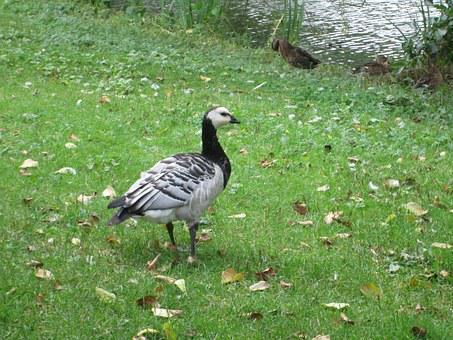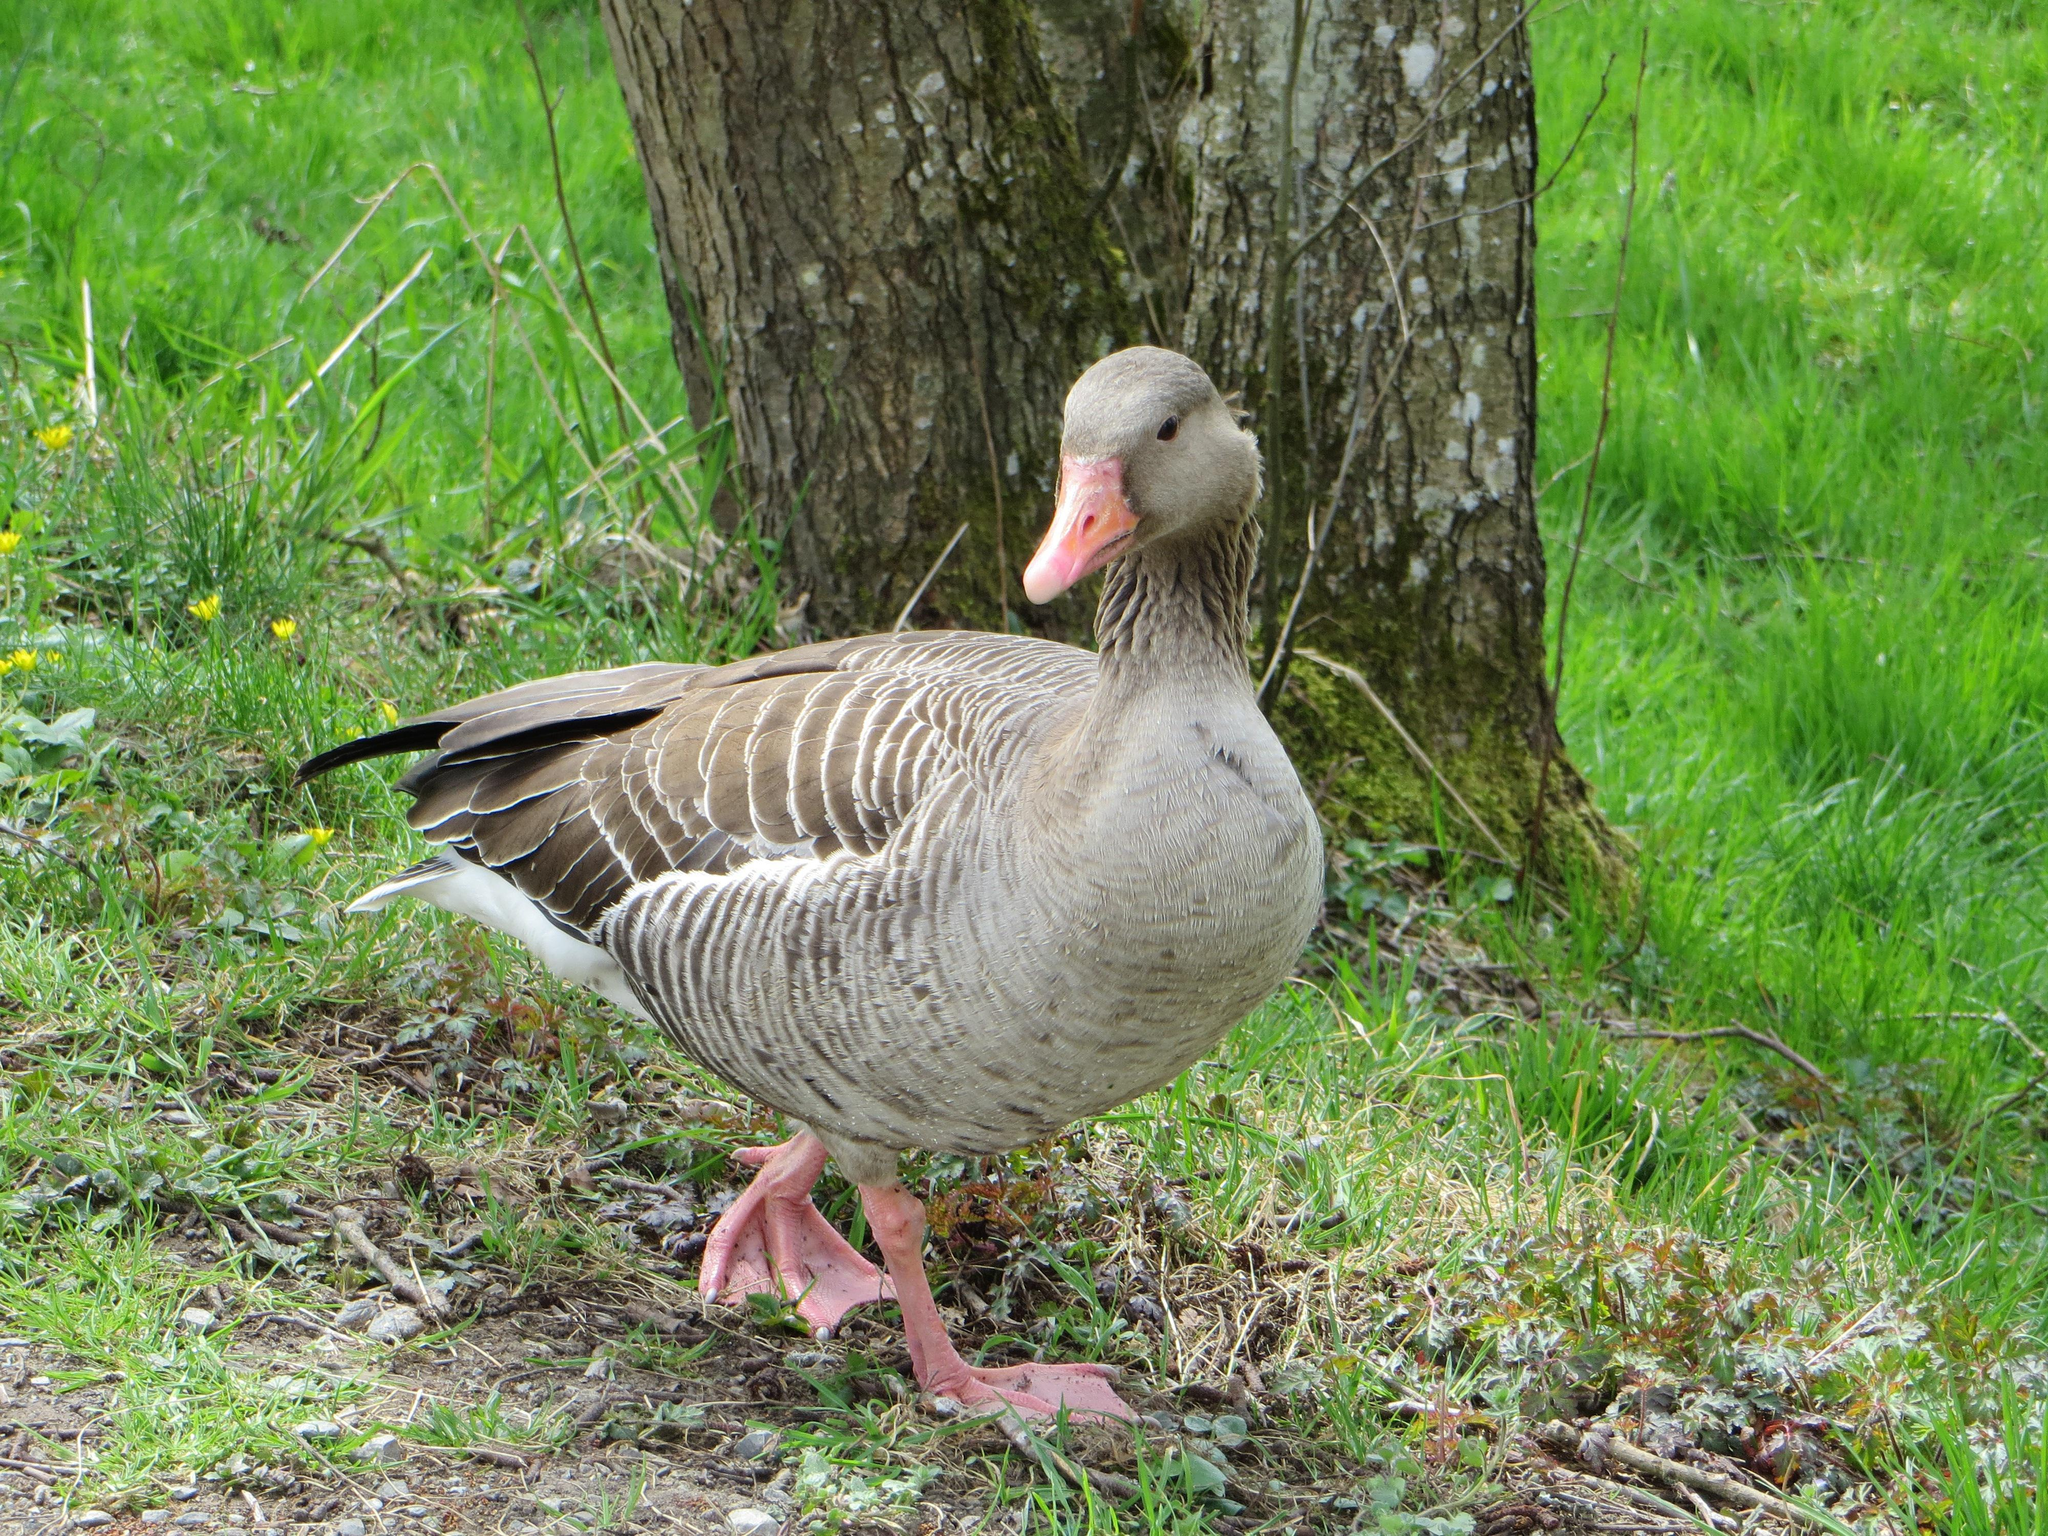The first image is the image on the left, the second image is the image on the right. Considering the images on both sides, is "Only geese with black and white faces are shown." valid? Answer yes or no. No. 